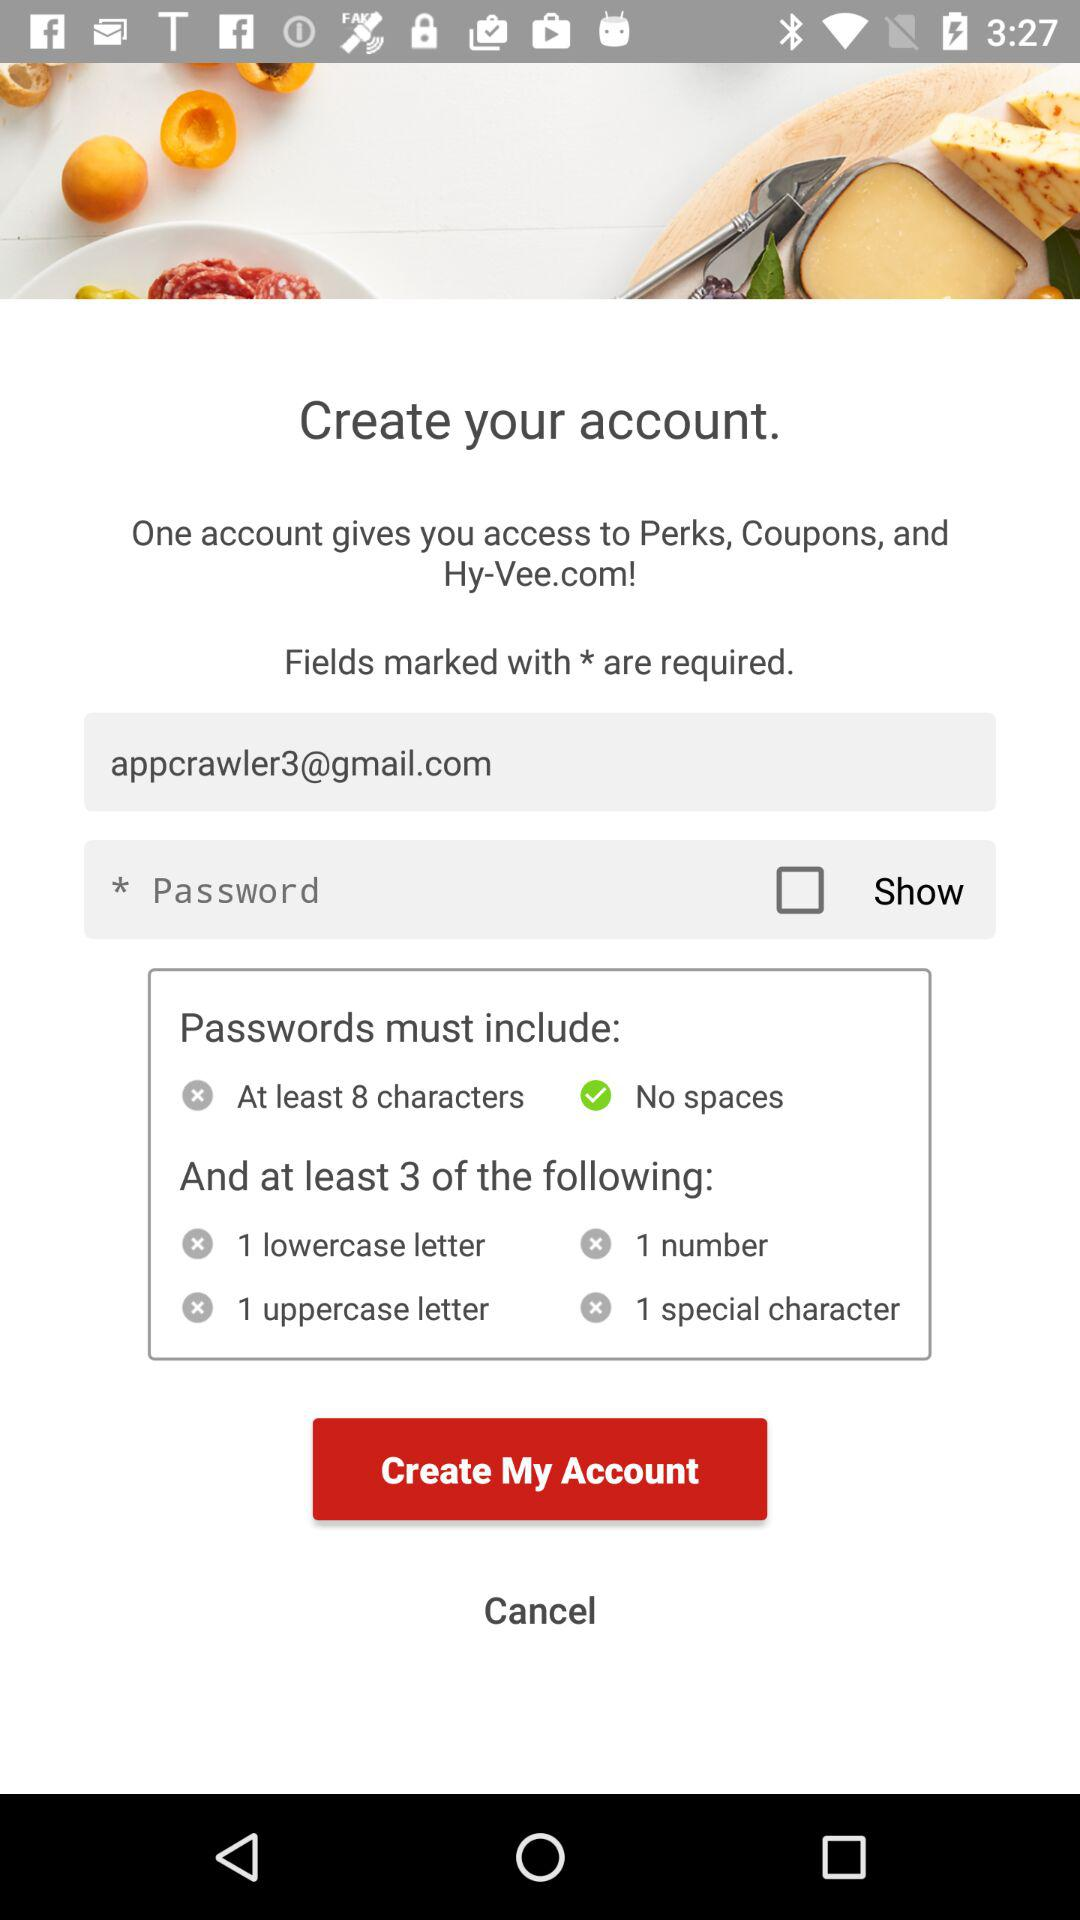What is the email address? The email address is appcrawler3@gmail.com. 